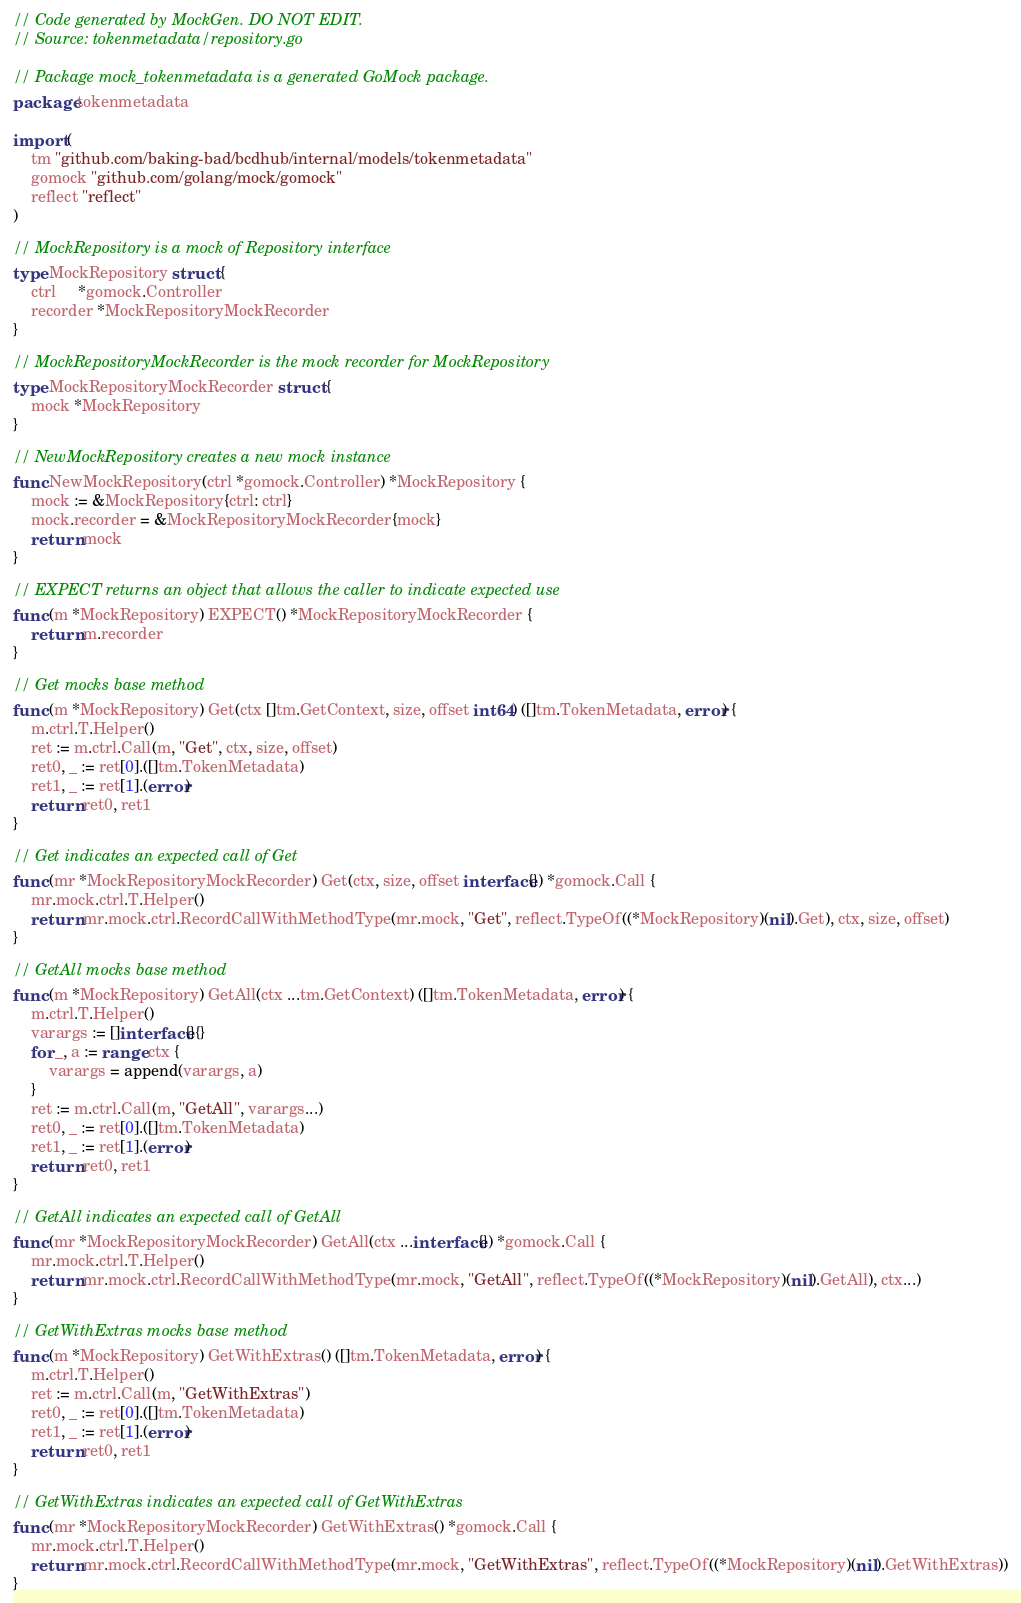<code> <loc_0><loc_0><loc_500><loc_500><_Go_>// Code generated by MockGen. DO NOT EDIT.
// Source: tokenmetadata/repository.go

// Package mock_tokenmetadata is a generated GoMock package.
package tokenmetadata

import (
	tm "github.com/baking-bad/bcdhub/internal/models/tokenmetadata"
	gomock "github.com/golang/mock/gomock"
	reflect "reflect"
)

// MockRepository is a mock of Repository interface
type MockRepository struct {
	ctrl     *gomock.Controller
	recorder *MockRepositoryMockRecorder
}

// MockRepositoryMockRecorder is the mock recorder for MockRepository
type MockRepositoryMockRecorder struct {
	mock *MockRepository
}

// NewMockRepository creates a new mock instance
func NewMockRepository(ctrl *gomock.Controller) *MockRepository {
	mock := &MockRepository{ctrl: ctrl}
	mock.recorder = &MockRepositoryMockRecorder{mock}
	return mock
}

// EXPECT returns an object that allows the caller to indicate expected use
func (m *MockRepository) EXPECT() *MockRepositoryMockRecorder {
	return m.recorder
}

// Get mocks base method
func (m *MockRepository) Get(ctx []tm.GetContext, size, offset int64) ([]tm.TokenMetadata, error) {
	m.ctrl.T.Helper()
	ret := m.ctrl.Call(m, "Get", ctx, size, offset)
	ret0, _ := ret[0].([]tm.TokenMetadata)
	ret1, _ := ret[1].(error)
	return ret0, ret1
}

// Get indicates an expected call of Get
func (mr *MockRepositoryMockRecorder) Get(ctx, size, offset interface{}) *gomock.Call {
	mr.mock.ctrl.T.Helper()
	return mr.mock.ctrl.RecordCallWithMethodType(mr.mock, "Get", reflect.TypeOf((*MockRepository)(nil).Get), ctx, size, offset)
}

// GetAll mocks base method
func (m *MockRepository) GetAll(ctx ...tm.GetContext) ([]tm.TokenMetadata, error) {
	m.ctrl.T.Helper()
	varargs := []interface{}{}
	for _, a := range ctx {
		varargs = append(varargs, a)
	}
	ret := m.ctrl.Call(m, "GetAll", varargs...)
	ret0, _ := ret[0].([]tm.TokenMetadata)
	ret1, _ := ret[1].(error)
	return ret0, ret1
}

// GetAll indicates an expected call of GetAll
func (mr *MockRepositoryMockRecorder) GetAll(ctx ...interface{}) *gomock.Call {
	mr.mock.ctrl.T.Helper()
	return mr.mock.ctrl.RecordCallWithMethodType(mr.mock, "GetAll", reflect.TypeOf((*MockRepository)(nil).GetAll), ctx...)
}

// GetWithExtras mocks base method
func (m *MockRepository) GetWithExtras() ([]tm.TokenMetadata, error) {
	m.ctrl.T.Helper()
	ret := m.ctrl.Call(m, "GetWithExtras")
	ret0, _ := ret[0].([]tm.TokenMetadata)
	ret1, _ := ret[1].(error)
	return ret0, ret1
}

// GetWithExtras indicates an expected call of GetWithExtras
func (mr *MockRepositoryMockRecorder) GetWithExtras() *gomock.Call {
	mr.mock.ctrl.T.Helper()
	return mr.mock.ctrl.RecordCallWithMethodType(mr.mock, "GetWithExtras", reflect.TypeOf((*MockRepository)(nil).GetWithExtras))
}
</code> 